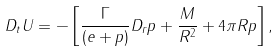Convert formula to latex. <formula><loc_0><loc_0><loc_500><loc_500>D _ { t } U = - \left [ \frac { \Gamma } { ( e + p ) } D _ { r } p + \frac { M } { R ^ { 2 } } + 4 \pi R p \right ] ,</formula> 